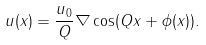<formula> <loc_0><loc_0><loc_500><loc_500>u ( x ) = \frac { u _ { 0 } } { Q } \nabla \cos ( Q x + \phi ( x ) ) .</formula> 